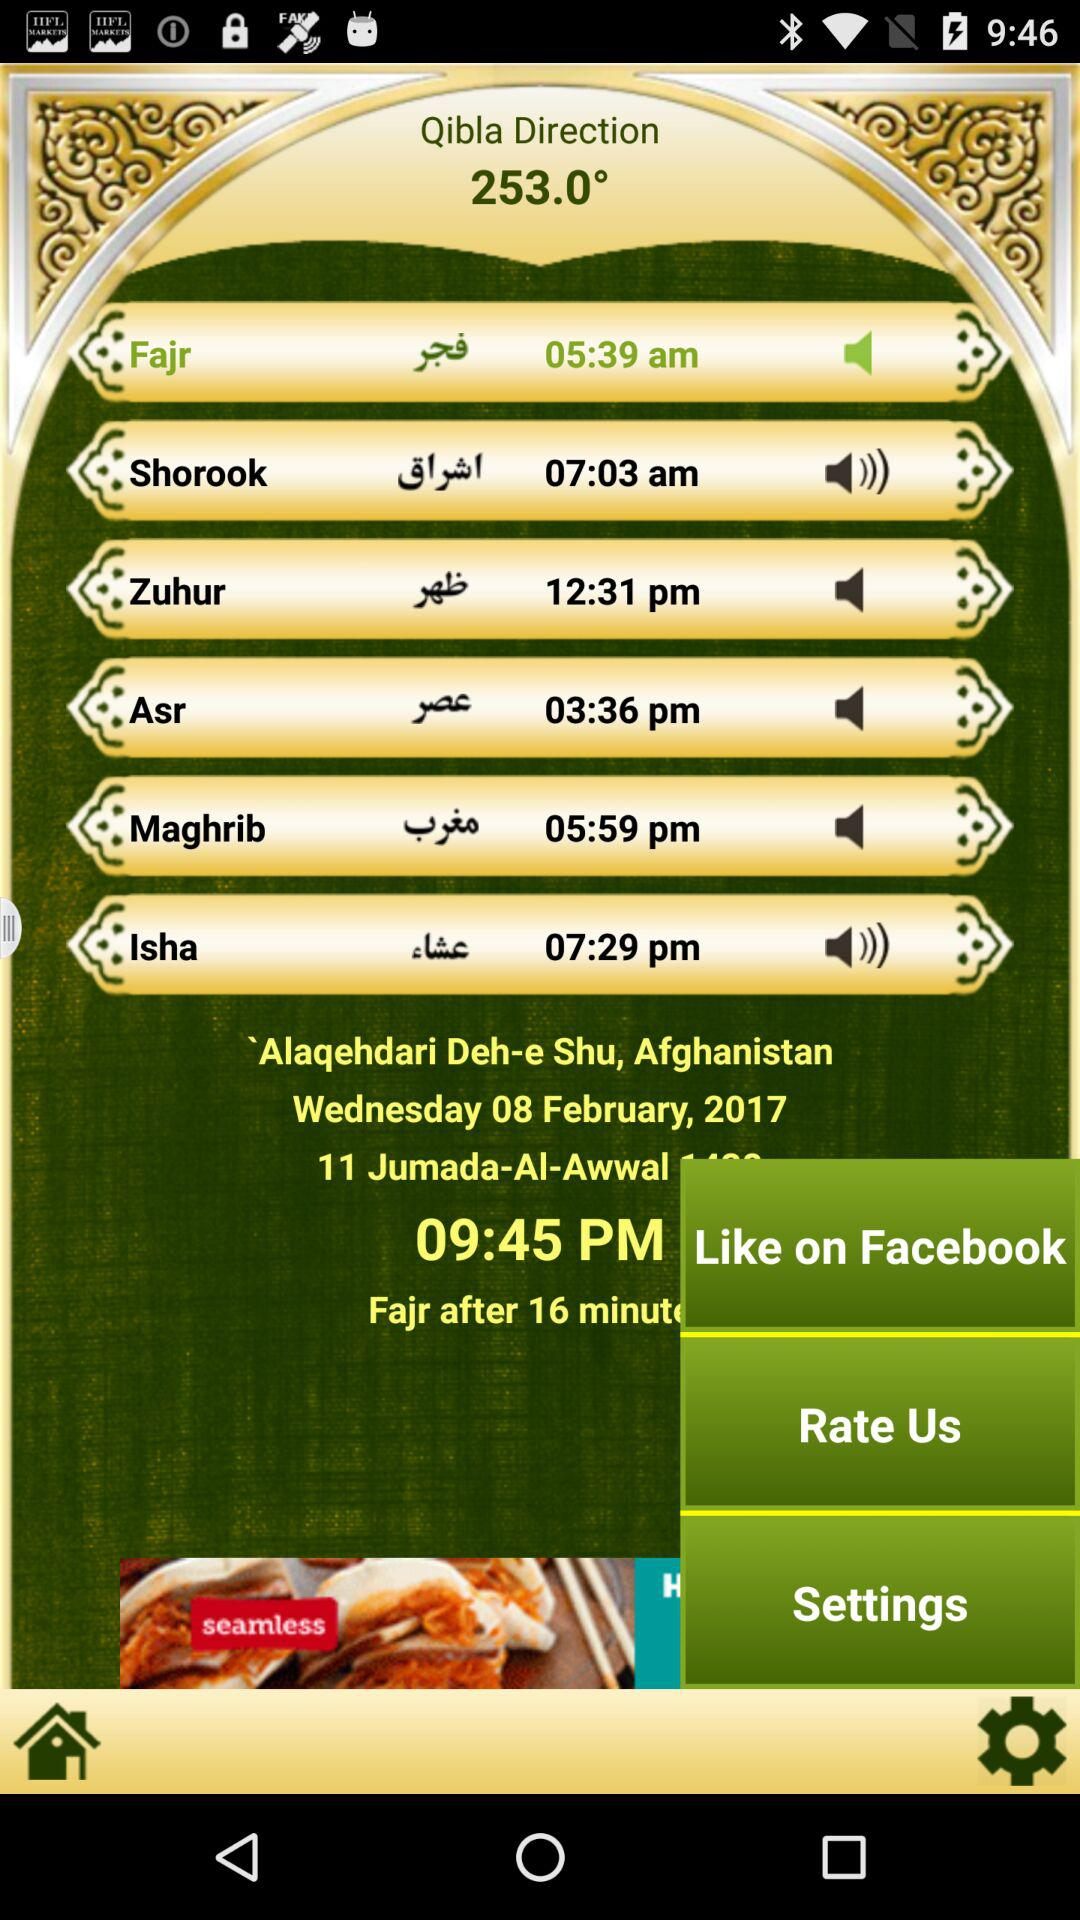What is the day and date? The day and date are Wednesday and February 8, 2017 respectively. 